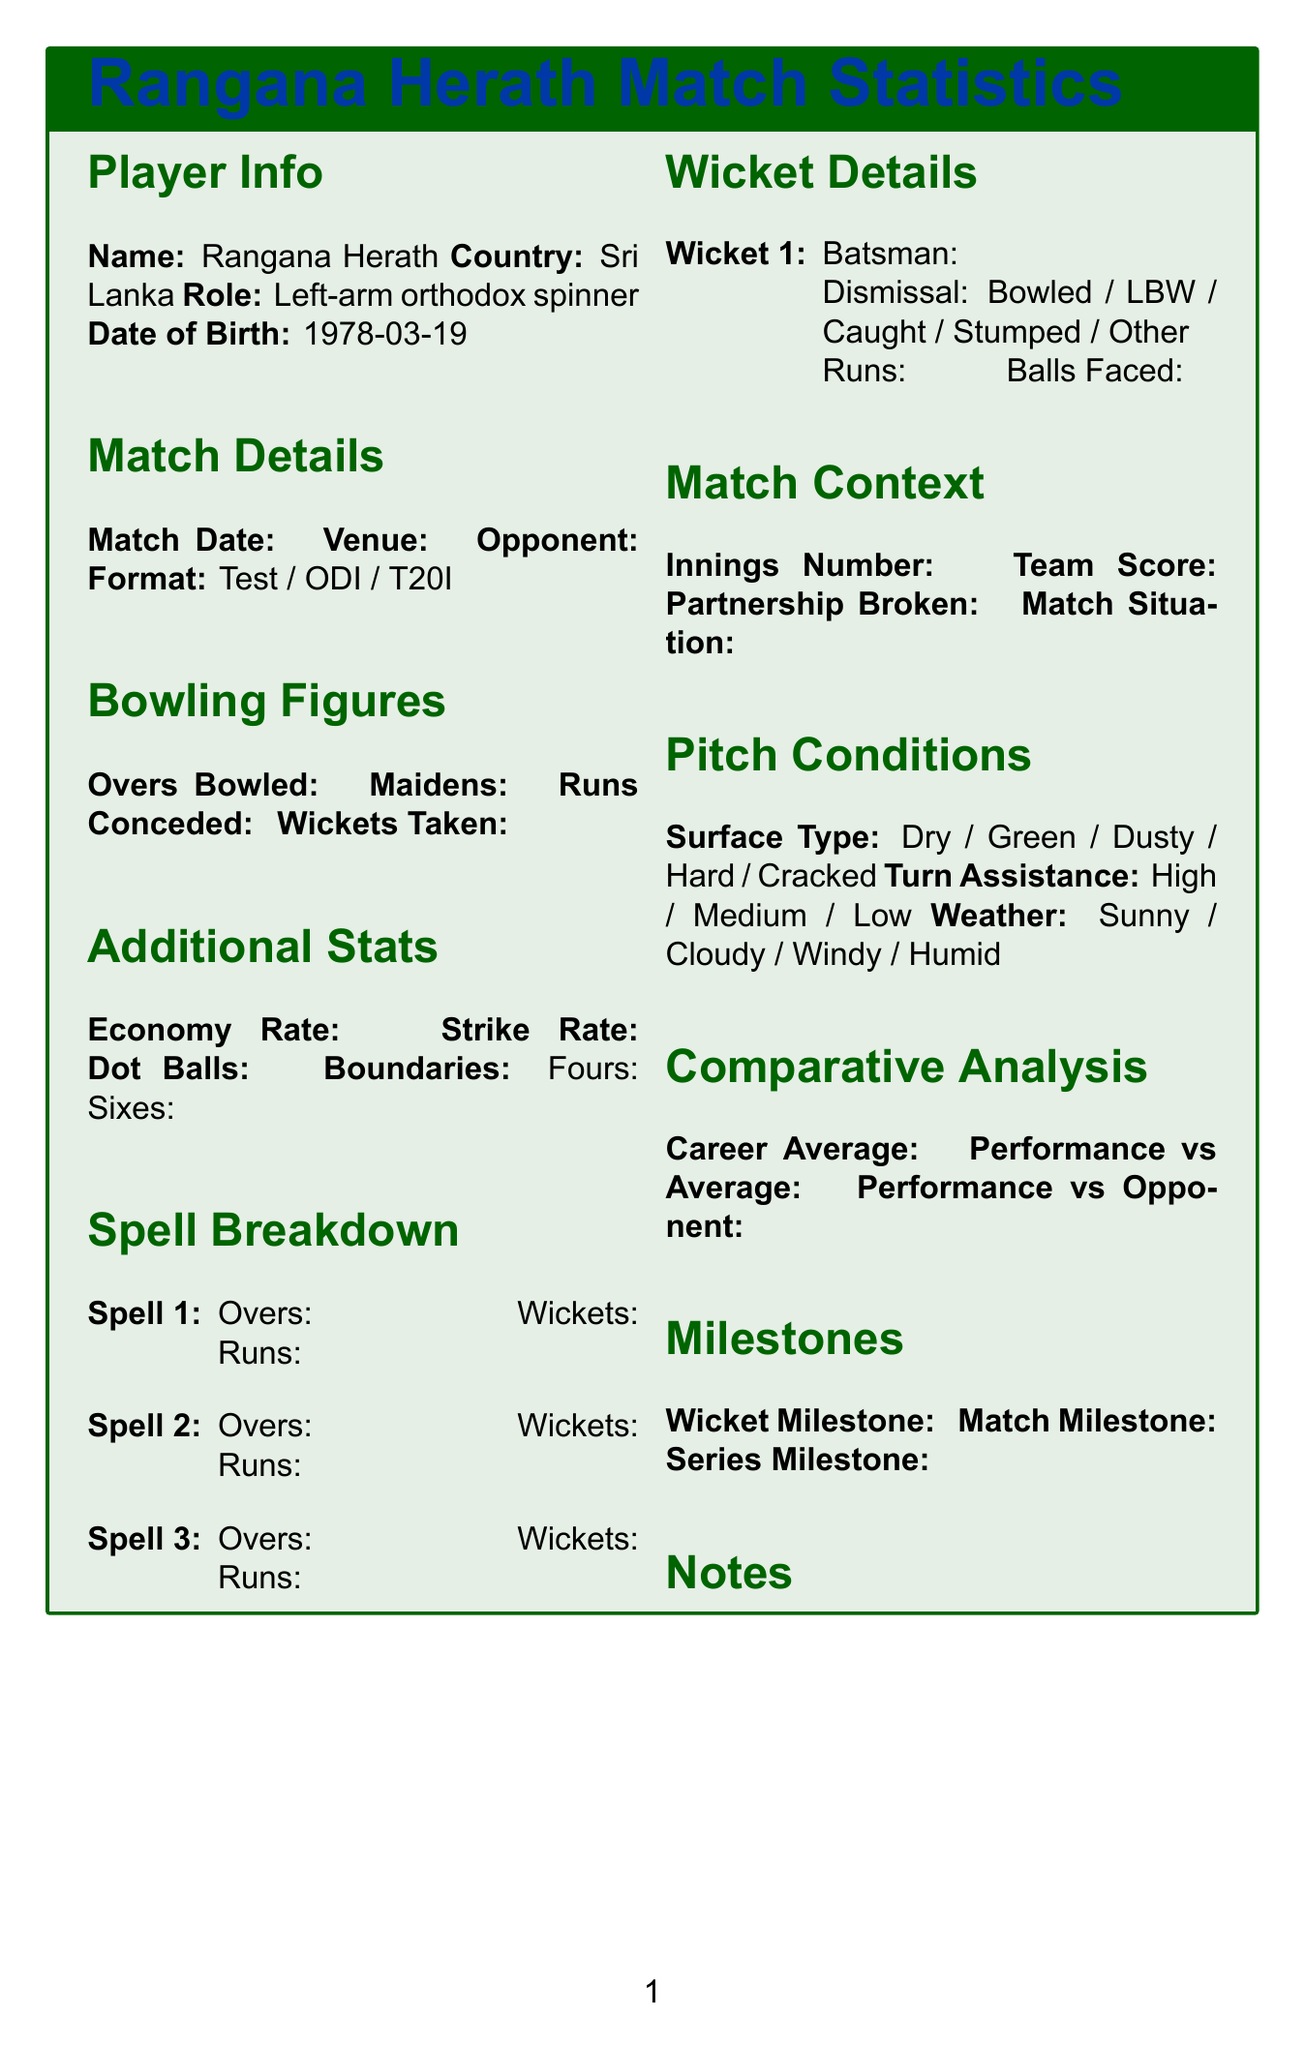what is Rangana Herath's role in the team? The role of Rangana Herath is mentioned as "Left-arm orthodox spinner."
Answer: Left-arm orthodox spinner when was Rangana Herath born? The date of birth of Rangana Herath is specified in the document.
Answer: 1978-03-19 what is the format of the match? The formats listed for the match are "Test, ODI, T20I."
Answer: Test / ODI / T20I what is the total number of spells bowled? The document outlines a section for spell breakdown for three spells, indicating the count.
Answer: 3 what information is provided in the wicket details section? The wicket details contain batsman's name, dismissal type, runs, and balls faced.
Answer: Batsman's name, Dismissal type, Runs, Balls faced what does the pitch conditions section include? The pitch conditions detail surface type, turn assistance, and weather conditions.
Answer: Surface type, Turn assistance, Weather conditions what does the comparative analysis section compare? The comparative analysis looks at career average and performance against average and opponent.
Answer: Career average, Performance vs Average, Performance vs Opponent what is the purpose of the milestones section? The milestones section is specified to track various achievements like wickets, matches, and series milestones.
Answer: Wicket milestone, Match milestone, Series milestone 